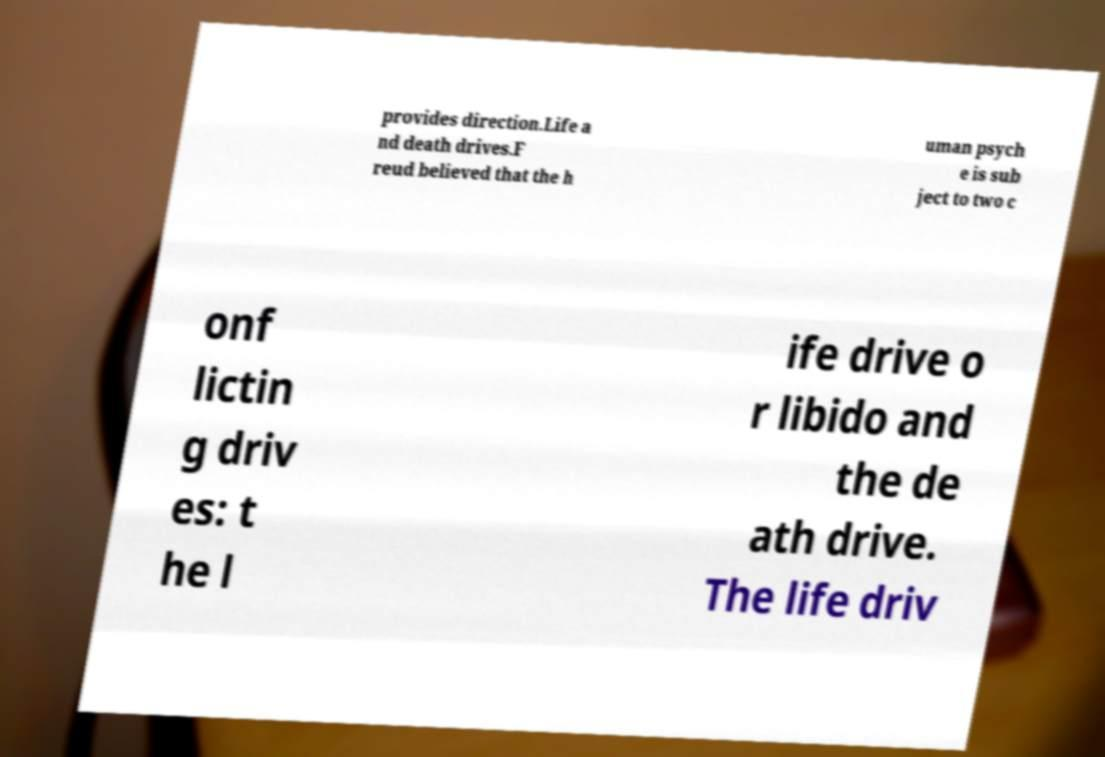Please read and relay the text visible in this image. What does it say? provides direction.Life a nd death drives.F reud believed that the h uman psych e is sub ject to two c onf lictin g driv es: t he l ife drive o r libido and the de ath drive. The life driv 